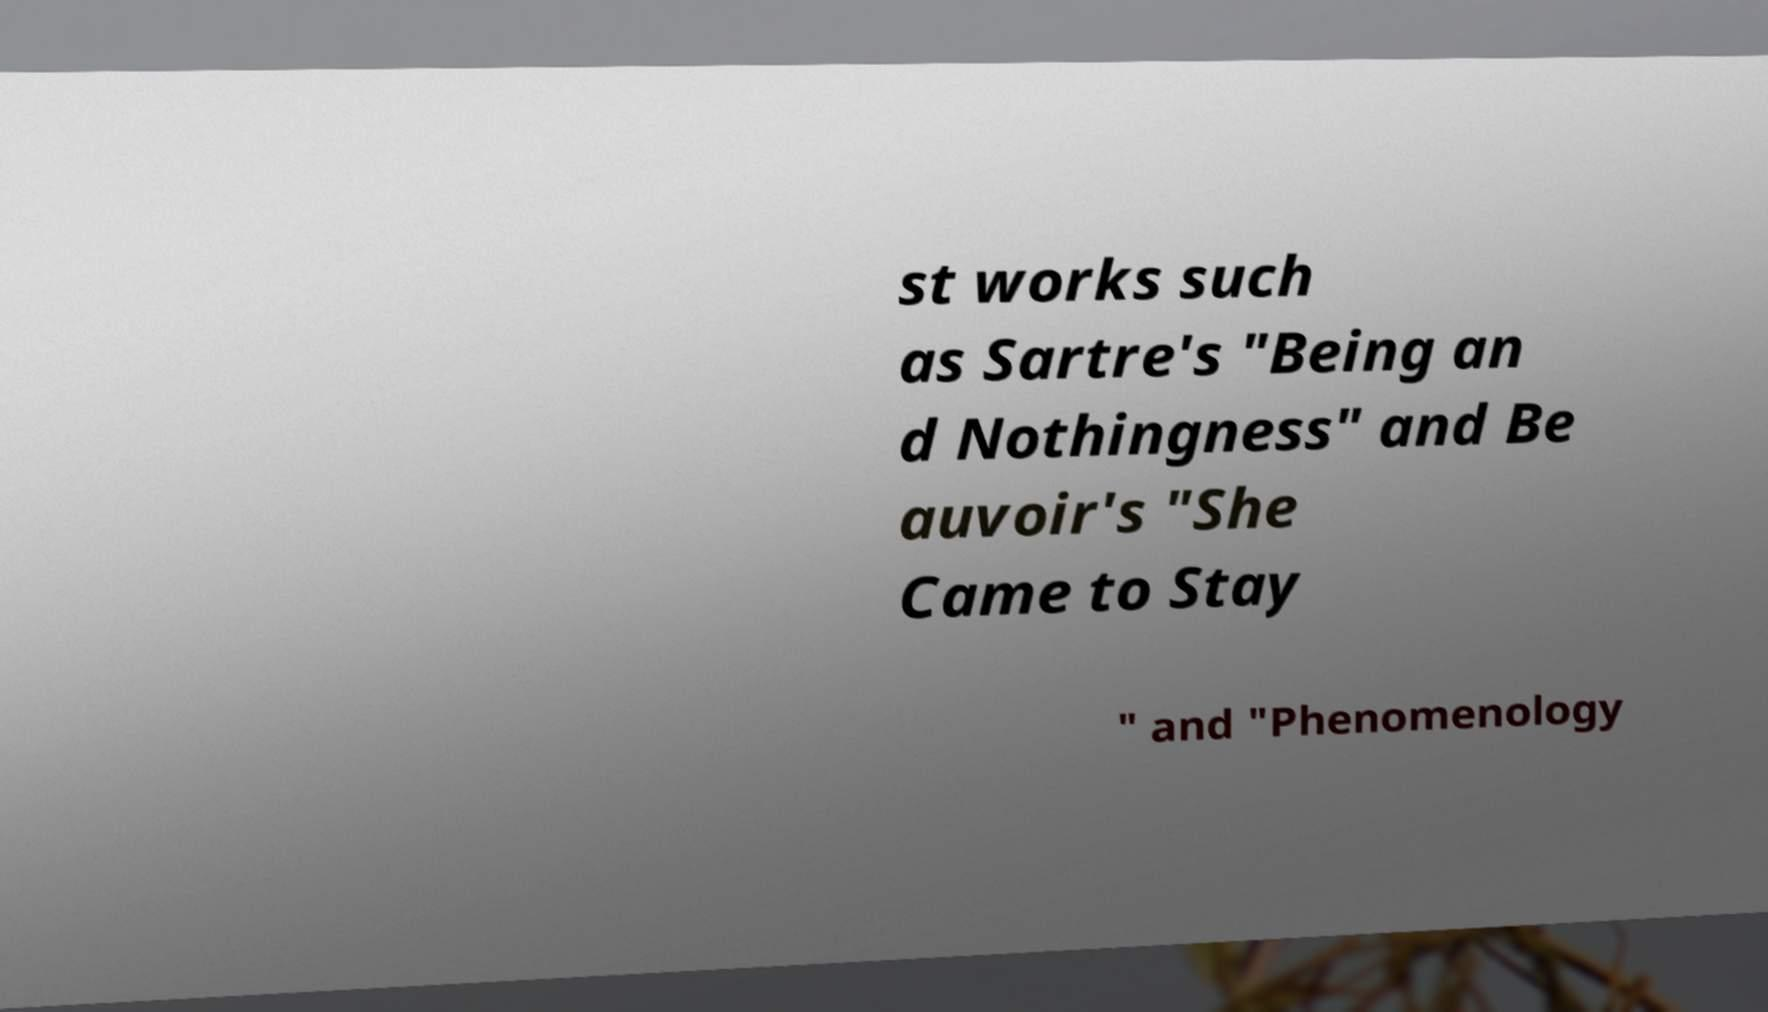Please read and relay the text visible in this image. What does it say? st works such as Sartre's "Being an d Nothingness" and Be auvoir's "She Came to Stay " and "Phenomenology 